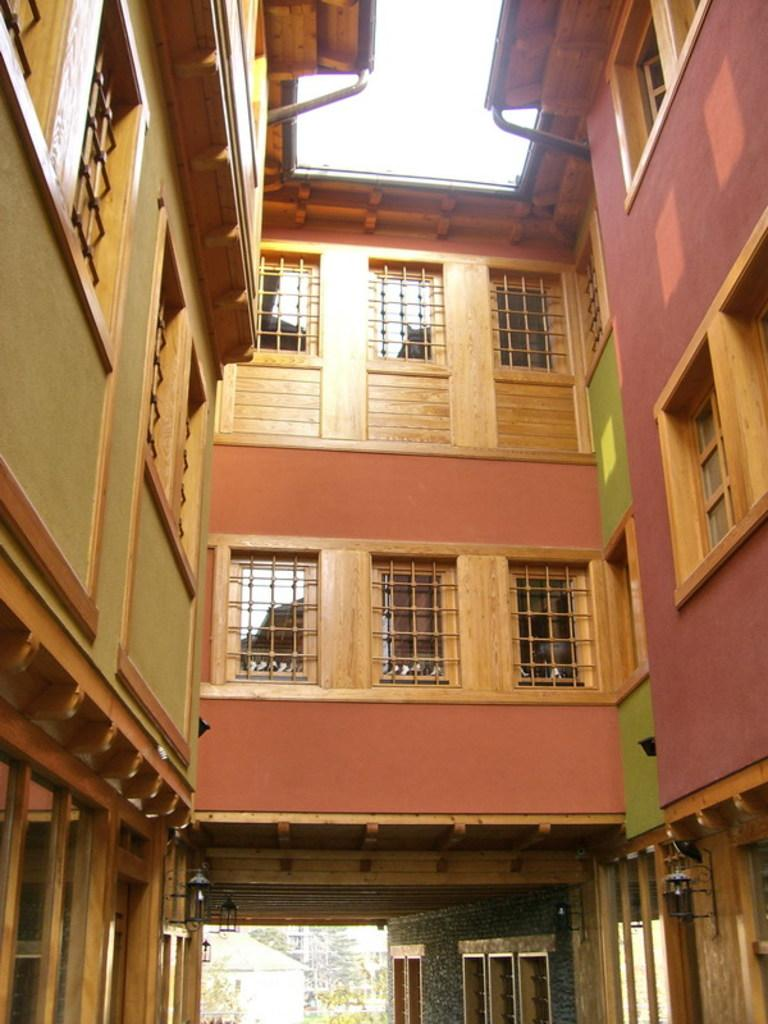What type of structures can be seen in the image? There are buildings with windows in the image. What is located in the background of the image? There is a shed and trees in the background of the image. What can be seen in the sky in the image? The sky is visible in the background of the image. What type of pipe is visible in the image? There is no pipe present in the image. How many dolls can be seen in the image? There are no dolls present in the image. 